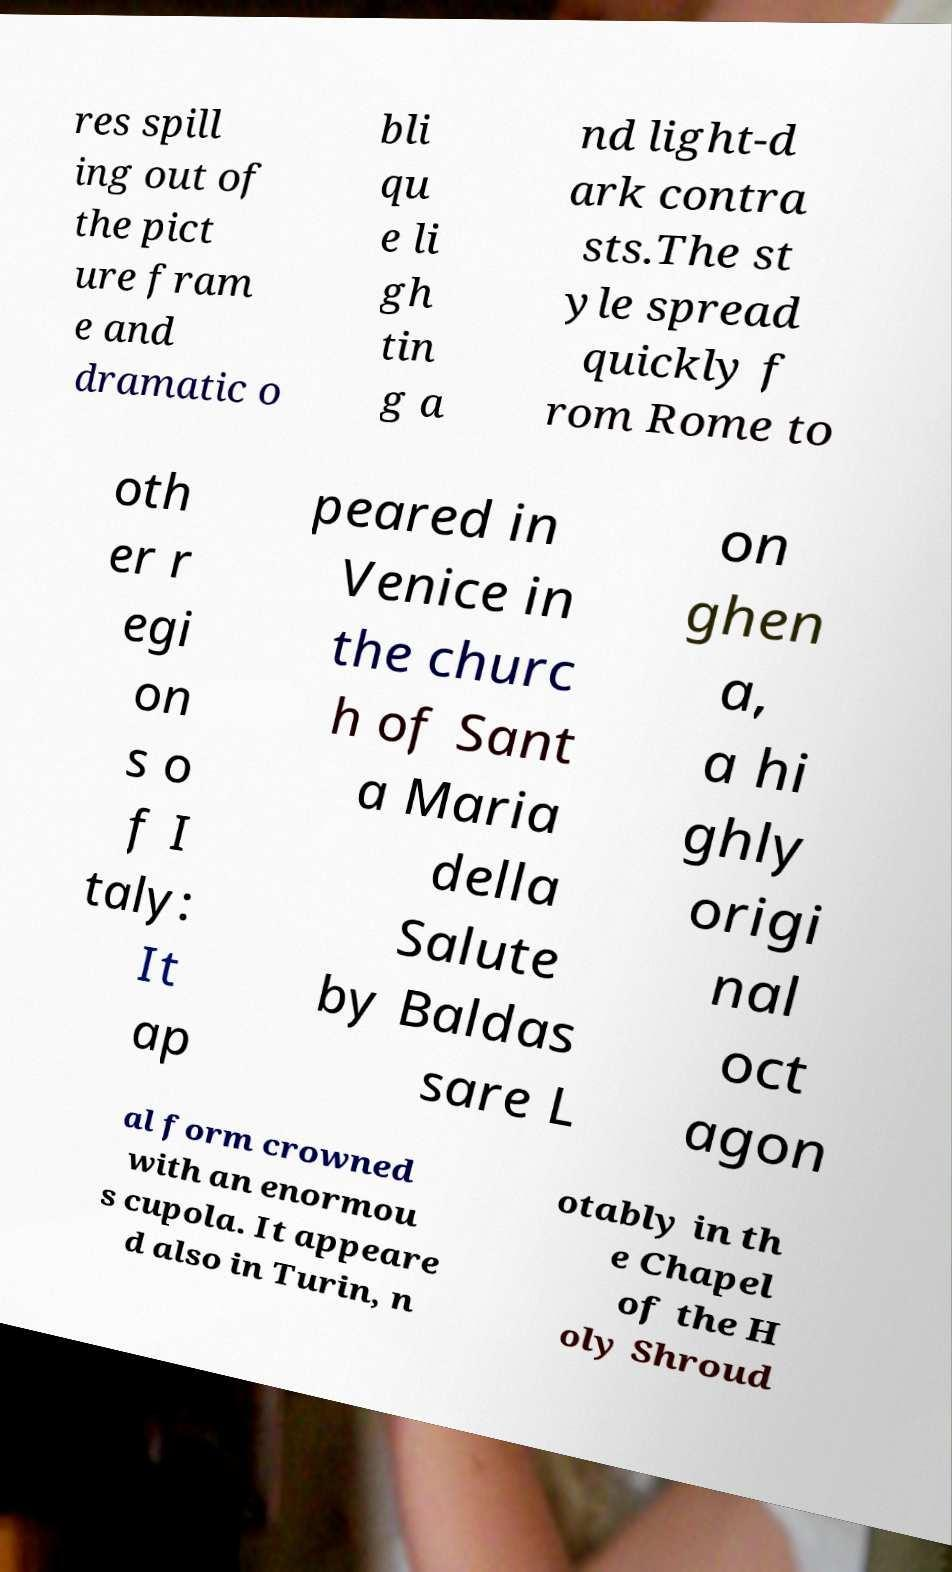Can you accurately transcribe the text from the provided image for me? res spill ing out of the pict ure fram e and dramatic o bli qu e li gh tin g a nd light-d ark contra sts.The st yle spread quickly f rom Rome to oth er r egi on s o f I taly: It ap peared in Venice in the churc h of Sant a Maria della Salute by Baldas sare L on ghen a, a hi ghly origi nal oct agon al form crowned with an enormou s cupola. It appeare d also in Turin, n otably in th e Chapel of the H oly Shroud 